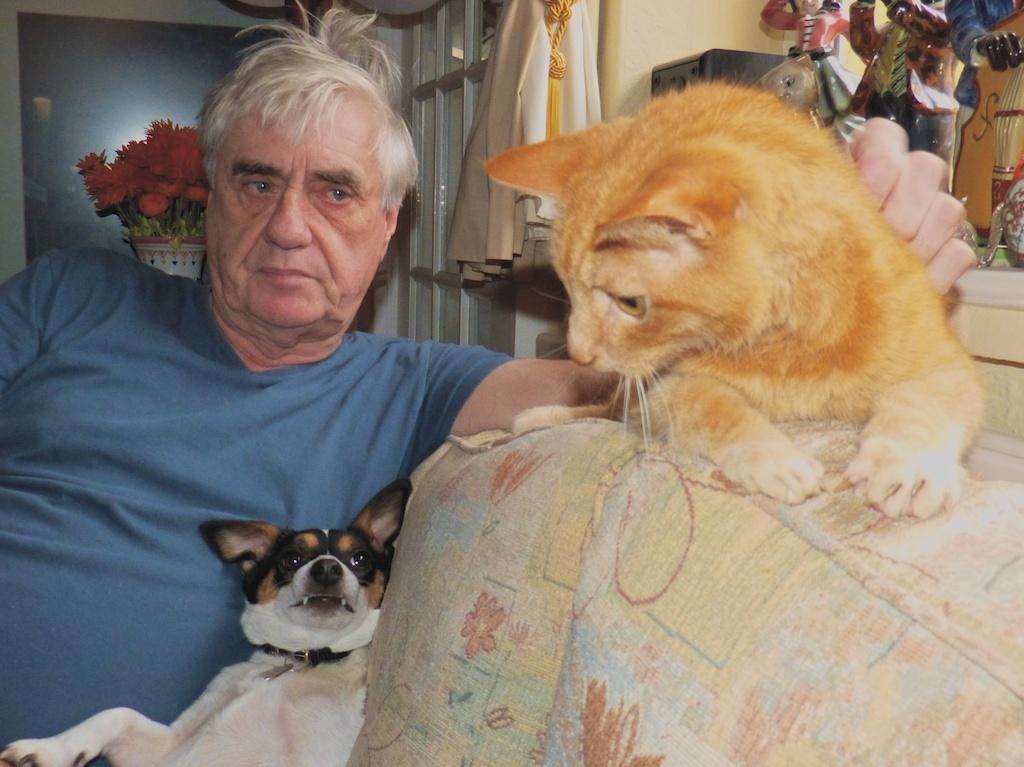Can you describe this image briefly? In the image a man is sitting. Beside him there is a dog and cat. Behind him wall and flower pot. 